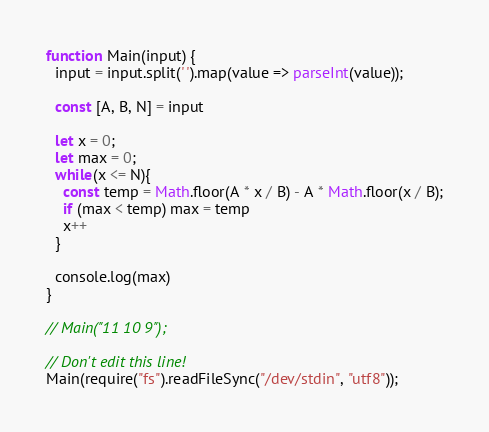Convert code to text. <code><loc_0><loc_0><loc_500><loc_500><_JavaScript_>function Main(input) {
  input = input.split(' ').map(value => parseInt(value));

  const [A, B, N] = input

  let x = 0;
  let max = 0;
  while(x <= N){
    const temp = Math.floor(A * x / B) - A * Math.floor(x / B);
    if (max < temp) max = temp
    x++
  }

  console.log(max)
}

// Main("11 10 9");

// Don't edit this line!
Main(require("fs").readFileSync("/dev/stdin", "utf8"));</code> 